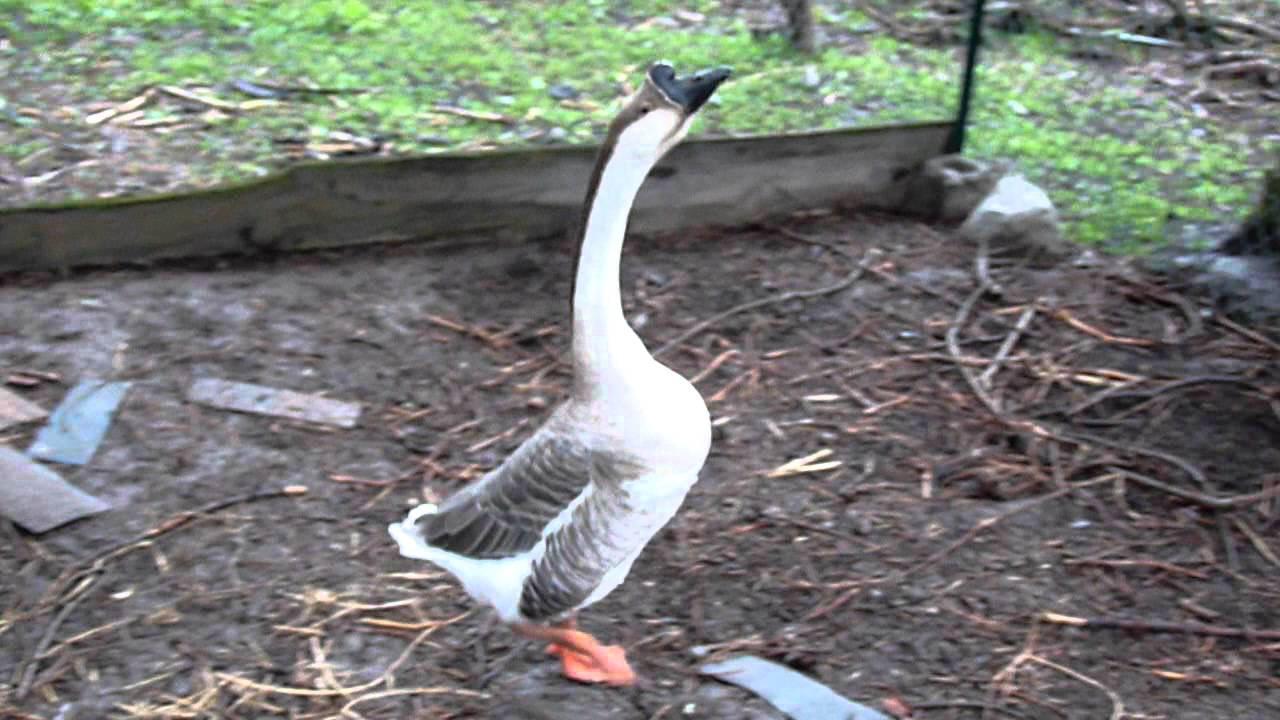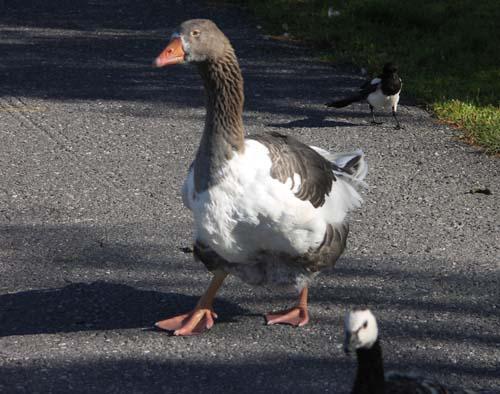The first image is the image on the left, the second image is the image on the right. For the images displayed, is the sentence "There are exactly two ducks." factually correct? Answer yes or no. Yes. The first image is the image on the left, the second image is the image on the right. Assess this claim about the two images: "An image shows one black-beaked goose standing on the water's edge.". Correct or not? Answer yes or no. No. 